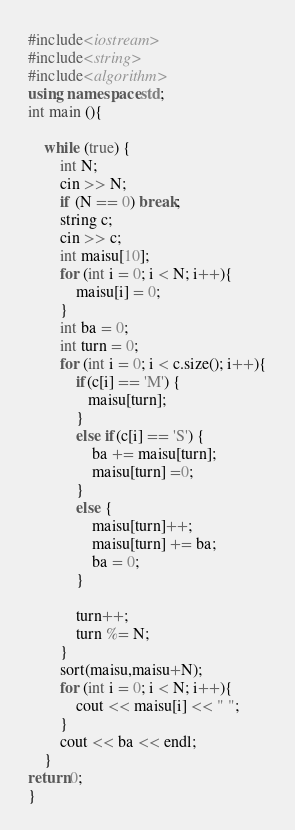Convert code to text. <code><loc_0><loc_0><loc_500><loc_500><_C++_>#include<iostream>
#include<string>
#include<algorithm>
using namespace std;
int main (){

	while (true) {
		int N;
		cin >> N;
		if (N == 0) break;
		string c;
		cin >> c;
		int maisu[10];
		for (int i = 0; i < N; i++){
			maisu[i] = 0;
		}
		int ba = 0;
		int turn = 0;
		for (int i = 0; i < c.size(); i++){
			if(c[i] == 'M') {
			   maisu[turn];
			}
			else if(c[i] == 'S') {
				ba += maisu[turn];
				maisu[turn] =0;
			}
			else {
				maisu[turn]++;
				maisu[turn] += ba;
				ba = 0;
			}
			
			turn++;
			turn %= N;
		}
		sort(maisu,maisu+N);
		for (int i = 0; i < N; i++){
			cout << maisu[i] << " ";
		}
		cout << ba << endl;
	}
return 0;
}</code> 